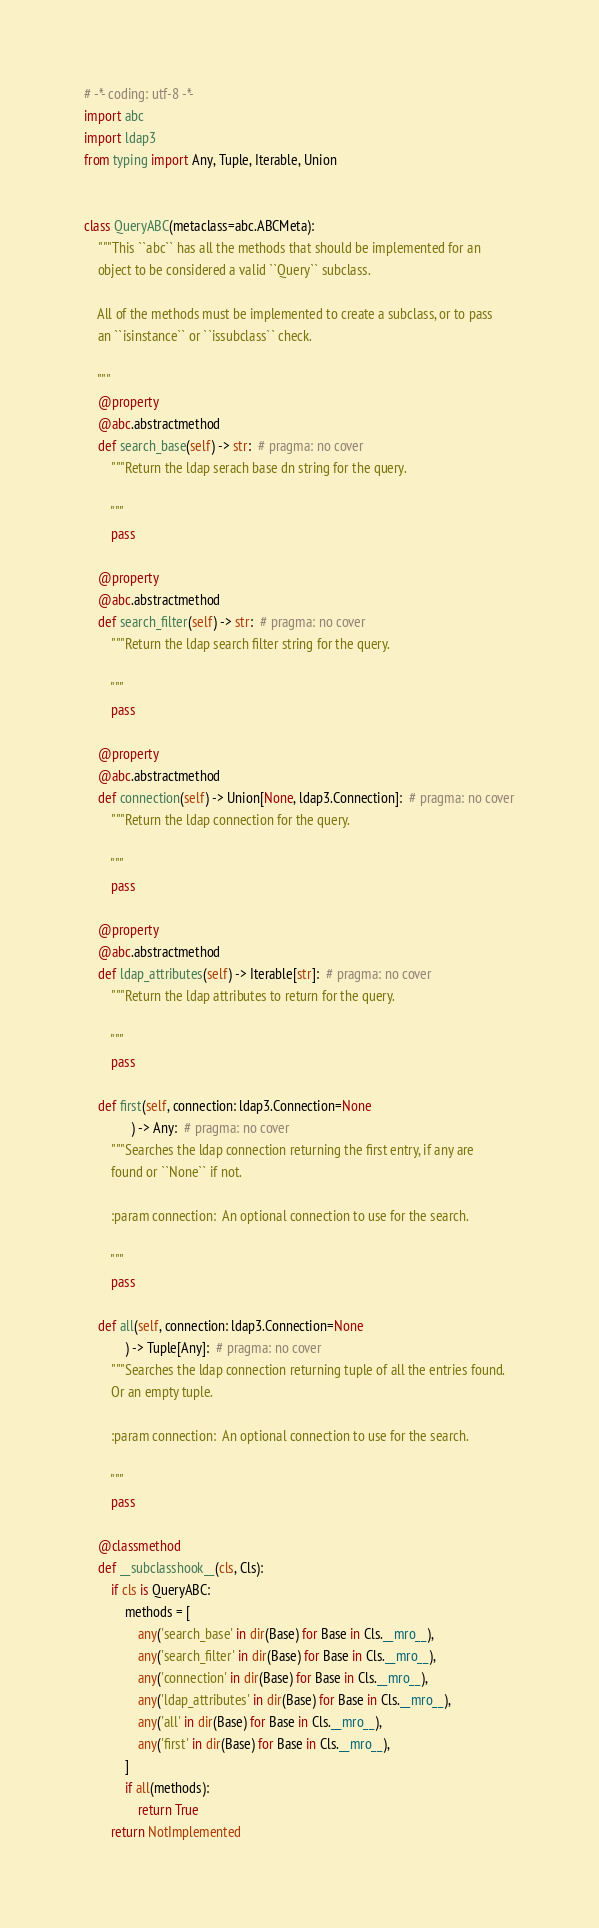Convert code to text. <code><loc_0><loc_0><loc_500><loc_500><_Python_># -*- coding: utf-8 -*-
import abc
import ldap3
from typing import Any, Tuple, Iterable, Union


class QueryABC(metaclass=abc.ABCMeta):
    """This ``abc`` has all the methods that should be implemented for an
    object to be considered a valid ``Query`` subclass.

    All of the methods must be implemented to create a subclass, or to pass
    an ``isinstance`` or ``issubclass`` check.

    """
    @property
    @abc.abstractmethod
    def search_base(self) -> str:  # pragma: no cover
        """Return the ldap serach base dn string for the query.

        """
        pass

    @property
    @abc.abstractmethod
    def search_filter(self) -> str:  # pragma: no cover
        """Return the ldap search filter string for the query.

        """
        pass

    @property
    @abc.abstractmethod
    def connection(self) -> Union[None, ldap3.Connection]:  # pragma: no cover
        """Return the ldap connection for the query.

        """
        pass

    @property
    @abc.abstractmethod
    def ldap_attributes(self) -> Iterable[str]:  # pragma: no cover
        """Return the ldap attributes to return for the query.

        """
        pass

    def first(self, connection: ldap3.Connection=None
              ) -> Any:  # pragma: no cover
        """Searches the ldap connection returning the first entry, if any are
        found or ``None`` if not.

        :param connection:  An optional connection to use for the search.

        """
        pass

    def all(self, connection: ldap3.Connection=None
            ) -> Tuple[Any]:  # pragma: no cover
        """Searches the ldap connection returning tuple of all the entries found.
        Or an empty tuple.

        :param connection:  An optional connection to use for the search.

        """
        pass

    @classmethod
    def __subclasshook__(cls, Cls):
        if cls is QueryABC:
            methods = [
                any('search_base' in dir(Base) for Base in Cls.__mro__),
                any('search_filter' in dir(Base) for Base in Cls.__mro__),
                any('connection' in dir(Base) for Base in Cls.__mro__),
                any('ldap_attributes' in dir(Base) for Base in Cls.__mro__),
                any('all' in dir(Base) for Base in Cls.__mro__),
                any('first' in dir(Base) for Base in Cls.__mro__),
            ]
            if all(methods):
                return True
        return NotImplemented
</code> 